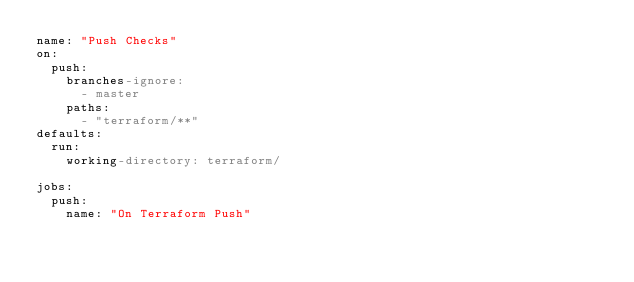Convert code to text. <code><loc_0><loc_0><loc_500><loc_500><_YAML_>name: "Push Checks"
on:
  push:
    branches-ignore:
      - master
    paths:
      - "terraform/**"
defaults:
  run:
    working-directory: terraform/

jobs:
  push:
    name: "On Terraform Push"</code> 